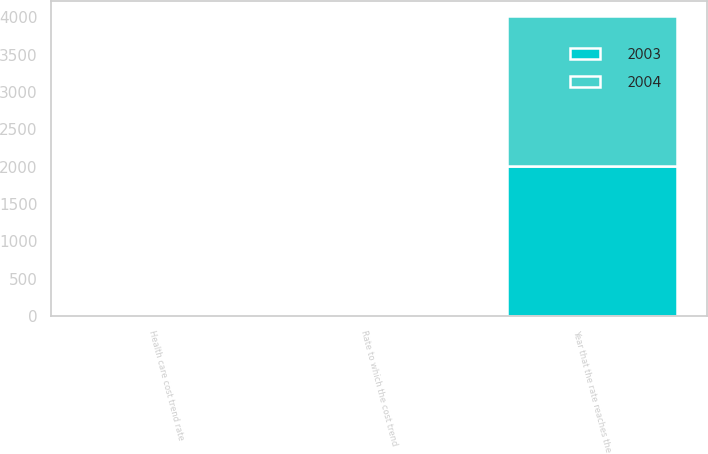Convert chart. <chart><loc_0><loc_0><loc_500><loc_500><stacked_bar_chart><ecel><fcel>Health care cost trend rate<fcel>Rate to which the cost trend<fcel>Year that the rate reaches the<nl><fcel>2003<fcel>11<fcel>5.5<fcel>2012<nl><fcel>2004<fcel>12<fcel>5.5<fcel>2012<nl></chart> 